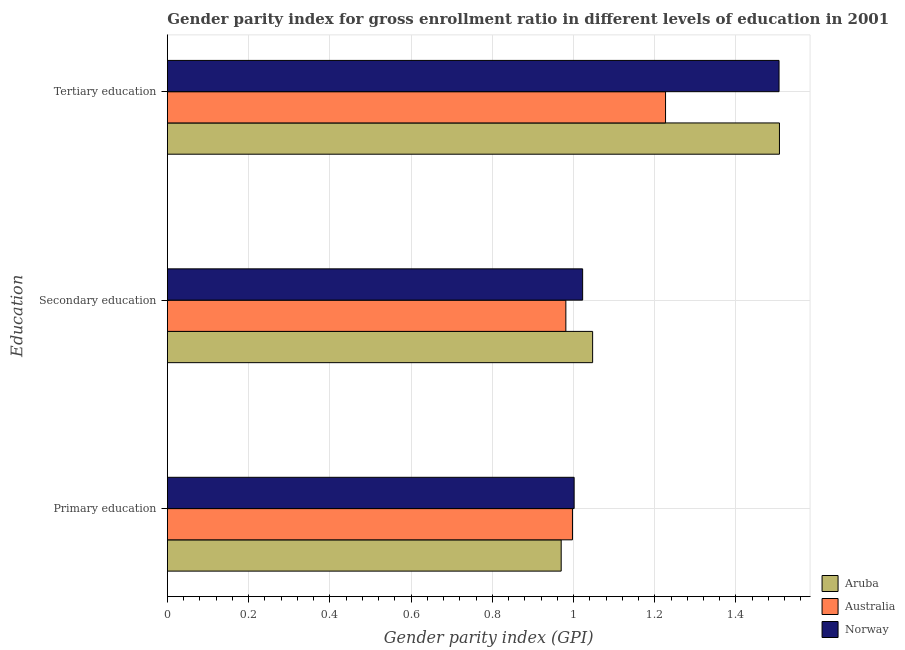How many groups of bars are there?
Give a very brief answer. 3. Are the number of bars per tick equal to the number of legend labels?
Your response must be concise. Yes. Are the number of bars on each tick of the Y-axis equal?
Your response must be concise. Yes. How many bars are there on the 1st tick from the top?
Provide a succinct answer. 3. How many bars are there on the 2nd tick from the bottom?
Provide a short and direct response. 3. What is the label of the 1st group of bars from the top?
Your answer should be compact. Tertiary education. What is the gender parity index in primary education in Aruba?
Your answer should be very brief. 0.97. Across all countries, what is the maximum gender parity index in primary education?
Make the answer very short. 1. Across all countries, what is the minimum gender parity index in primary education?
Make the answer very short. 0.97. In which country was the gender parity index in tertiary education minimum?
Keep it short and to the point. Australia. What is the total gender parity index in tertiary education in the graph?
Ensure brevity in your answer.  4.24. What is the difference between the gender parity index in secondary education in Norway and that in Aruba?
Provide a short and direct response. -0.02. What is the difference between the gender parity index in tertiary education in Australia and the gender parity index in secondary education in Aruba?
Offer a terse response. 0.18. What is the average gender parity index in secondary education per country?
Your answer should be very brief. 1.02. What is the difference between the gender parity index in tertiary education and gender parity index in primary education in Australia?
Make the answer very short. 0.23. In how many countries, is the gender parity index in tertiary education greater than 0.28 ?
Make the answer very short. 3. What is the ratio of the gender parity index in secondary education in Aruba to that in Norway?
Keep it short and to the point. 1.02. What is the difference between the highest and the second highest gender parity index in tertiary education?
Offer a terse response. 0. What is the difference between the highest and the lowest gender parity index in primary education?
Keep it short and to the point. 0.03. In how many countries, is the gender parity index in tertiary education greater than the average gender parity index in tertiary education taken over all countries?
Provide a succinct answer. 2. What does the 2nd bar from the top in Tertiary education represents?
Make the answer very short. Australia. What does the 1st bar from the bottom in Secondary education represents?
Offer a very short reply. Aruba. Is it the case that in every country, the sum of the gender parity index in primary education and gender parity index in secondary education is greater than the gender parity index in tertiary education?
Ensure brevity in your answer.  Yes. How many bars are there?
Offer a very short reply. 9. Are all the bars in the graph horizontal?
Make the answer very short. Yes. Does the graph contain any zero values?
Make the answer very short. No. Where does the legend appear in the graph?
Offer a terse response. Bottom right. How many legend labels are there?
Provide a short and direct response. 3. What is the title of the graph?
Give a very brief answer. Gender parity index for gross enrollment ratio in different levels of education in 2001. Does "Heavily indebted poor countries" appear as one of the legend labels in the graph?
Give a very brief answer. No. What is the label or title of the X-axis?
Give a very brief answer. Gender parity index (GPI). What is the label or title of the Y-axis?
Your answer should be very brief. Education. What is the Gender parity index (GPI) of Aruba in Primary education?
Your response must be concise. 0.97. What is the Gender parity index (GPI) in Australia in Primary education?
Your answer should be very brief. 1. What is the Gender parity index (GPI) in Norway in Primary education?
Give a very brief answer. 1. What is the Gender parity index (GPI) of Aruba in Secondary education?
Keep it short and to the point. 1.05. What is the Gender parity index (GPI) in Australia in Secondary education?
Your response must be concise. 0.98. What is the Gender parity index (GPI) of Norway in Secondary education?
Keep it short and to the point. 1.02. What is the Gender parity index (GPI) in Aruba in Tertiary education?
Your answer should be compact. 1.51. What is the Gender parity index (GPI) of Australia in Tertiary education?
Provide a succinct answer. 1.23. What is the Gender parity index (GPI) of Norway in Tertiary education?
Ensure brevity in your answer.  1.51. Across all Education, what is the maximum Gender parity index (GPI) of Aruba?
Give a very brief answer. 1.51. Across all Education, what is the maximum Gender parity index (GPI) in Australia?
Offer a terse response. 1.23. Across all Education, what is the maximum Gender parity index (GPI) of Norway?
Offer a very short reply. 1.51. Across all Education, what is the minimum Gender parity index (GPI) in Aruba?
Offer a terse response. 0.97. Across all Education, what is the minimum Gender parity index (GPI) in Australia?
Provide a succinct answer. 0.98. Across all Education, what is the minimum Gender parity index (GPI) of Norway?
Make the answer very short. 1. What is the total Gender parity index (GPI) of Aruba in the graph?
Keep it short and to the point. 3.52. What is the total Gender parity index (GPI) in Australia in the graph?
Offer a terse response. 3.21. What is the total Gender parity index (GPI) in Norway in the graph?
Your answer should be very brief. 3.53. What is the difference between the Gender parity index (GPI) in Aruba in Primary education and that in Secondary education?
Keep it short and to the point. -0.08. What is the difference between the Gender parity index (GPI) in Australia in Primary education and that in Secondary education?
Make the answer very short. 0.02. What is the difference between the Gender parity index (GPI) of Norway in Primary education and that in Secondary education?
Give a very brief answer. -0.02. What is the difference between the Gender parity index (GPI) of Aruba in Primary education and that in Tertiary education?
Make the answer very short. -0.54. What is the difference between the Gender parity index (GPI) in Australia in Primary education and that in Tertiary education?
Keep it short and to the point. -0.23. What is the difference between the Gender parity index (GPI) in Norway in Primary education and that in Tertiary education?
Your answer should be compact. -0.5. What is the difference between the Gender parity index (GPI) in Aruba in Secondary education and that in Tertiary education?
Give a very brief answer. -0.46. What is the difference between the Gender parity index (GPI) in Australia in Secondary education and that in Tertiary education?
Provide a short and direct response. -0.25. What is the difference between the Gender parity index (GPI) of Norway in Secondary education and that in Tertiary education?
Your answer should be very brief. -0.48. What is the difference between the Gender parity index (GPI) of Aruba in Primary education and the Gender parity index (GPI) of Australia in Secondary education?
Your answer should be compact. -0.01. What is the difference between the Gender parity index (GPI) of Aruba in Primary education and the Gender parity index (GPI) of Norway in Secondary education?
Your answer should be very brief. -0.05. What is the difference between the Gender parity index (GPI) of Australia in Primary education and the Gender parity index (GPI) of Norway in Secondary education?
Your response must be concise. -0.03. What is the difference between the Gender parity index (GPI) in Aruba in Primary education and the Gender parity index (GPI) in Australia in Tertiary education?
Your answer should be very brief. -0.26. What is the difference between the Gender parity index (GPI) of Aruba in Primary education and the Gender parity index (GPI) of Norway in Tertiary education?
Make the answer very short. -0.54. What is the difference between the Gender parity index (GPI) of Australia in Primary education and the Gender parity index (GPI) of Norway in Tertiary education?
Offer a terse response. -0.51. What is the difference between the Gender parity index (GPI) of Aruba in Secondary education and the Gender parity index (GPI) of Australia in Tertiary education?
Keep it short and to the point. -0.18. What is the difference between the Gender parity index (GPI) of Aruba in Secondary education and the Gender parity index (GPI) of Norway in Tertiary education?
Offer a terse response. -0.46. What is the difference between the Gender parity index (GPI) of Australia in Secondary education and the Gender parity index (GPI) of Norway in Tertiary education?
Offer a very short reply. -0.52. What is the average Gender parity index (GPI) in Aruba per Education?
Give a very brief answer. 1.17. What is the average Gender parity index (GPI) in Australia per Education?
Your answer should be compact. 1.07. What is the average Gender parity index (GPI) of Norway per Education?
Keep it short and to the point. 1.18. What is the difference between the Gender parity index (GPI) in Aruba and Gender parity index (GPI) in Australia in Primary education?
Your response must be concise. -0.03. What is the difference between the Gender parity index (GPI) in Aruba and Gender parity index (GPI) in Norway in Primary education?
Your answer should be very brief. -0.03. What is the difference between the Gender parity index (GPI) in Australia and Gender parity index (GPI) in Norway in Primary education?
Your answer should be very brief. -0. What is the difference between the Gender parity index (GPI) of Aruba and Gender parity index (GPI) of Australia in Secondary education?
Your answer should be very brief. 0.07. What is the difference between the Gender parity index (GPI) in Aruba and Gender parity index (GPI) in Norway in Secondary education?
Your answer should be compact. 0.02. What is the difference between the Gender parity index (GPI) in Australia and Gender parity index (GPI) in Norway in Secondary education?
Make the answer very short. -0.04. What is the difference between the Gender parity index (GPI) in Aruba and Gender parity index (GPI) in Australia in Tertiary education?
Offer a very short reply. 0.28. What is the difference between the Gender parity index (GPI) in Aruba and Gender parity index (GPI) in Norway in Tertiary education?
Ensure brevity in your answer.  0. What is the difference between the Gender parity index (GPI) of Australia and Gender parity index (GPI) of Norway in Tertiary education?
Your answer should be compact. -0.28. What is the ratio of the Gender parity index (GPI) in Aruba in Primary education to that in Secondary education?
Keep it short and to the point. 0.93. What is the ratio of the Gender parity index (GPI) of Australia in Primary education to that in Secondary education?
Ensure brevity in your answer.  1.02. What is the ratio of the Gender parity index (GPI) of Norway in Primary education to that in Secondary education?
Your answer should be very brief. 0.98. What is the ratio of the Gender parity index (GPI) of Aruba in Primary education to that in Tertiary education?
Make the answer very short. 0.64. What is the ratio of the Gender parity index (GPI) in Australia in Primary education to that in Tertiary education?
Your answer should be very brief. 0.81. What is the ratio of the Gender parity index (GPI) in Norway in Primary education to that in Tertiary education?
Give a very brief answer. 0.67. What is the ratio of the Gender parity index (GPI) of Aruba in Secondary education to that in Tertiary education?
Make the answer very short. 0.69. What is the ratio of the Gender parity index (GPI) in Australia in Secondary education to that in Tertiary education?
Your response must be concise. 0.8. What is the ratio of the Gender parity index (GPI) in Norway in Secondary education to that in Tertiary education?
Keep it short and to the point. 0.68. What is the difference between the highest and the second highest Gender parity index (GPI) in Aruba?
Ensure brevity in your answer.  0.46. What is the difference between the highest and the second highest Gender parity index (GPI) in Australia?
Provide a short and direct response. 0.23. What is the difference between the highest and the second highest Gender parity index (GPI) in Norway?
Provide a succinct answer. 0.48. What is the difference between the highest and the lowest Gender parity index (GPI) in Aruba?
Your answer should be very brief. 0.54. What is the difference between the highest and the lowest Gender parity index (GPI) in Australia?
Your answer should be compact. 0.25. What is the difference between the highest and the lowest Gender parity index (GPI) of Norway?
Provide a short and direct response. 0.5. 